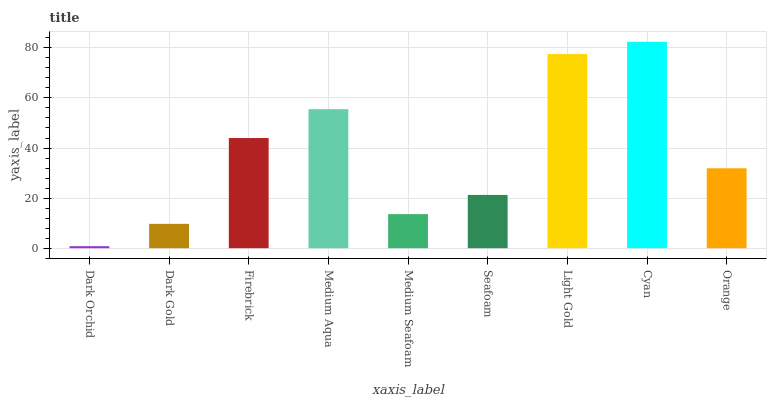Is Dark Orchid the minimum?
Answer yes or no. Yes. Is Cyan the maximum?
Answer yes or no. Yes. Is Dark Gold the minimum?
Answer yes or no. No. Is Dark Gold the maximum?
Answer yes or no. No. Is Dark Gold greater than Dark Orchid?
Answer yes or no. Yes. Is Dark Orchid less than Dark Gold?
Answer yes or no. Yes. Is Dark Orchid greater than Dark Gold?
Answer yes or no. No. Is Dark Gold less than Dark Orchid?
Answer yes or no. No. Is Orange the high median?
Answer yes or no. Yes. Is Orange the low median?
Answer yes or no. Yes. Is Seafoam the high median?
Answer yes or no. No. Is Medium Seafoam the low median?
Answer yes or no. No. 